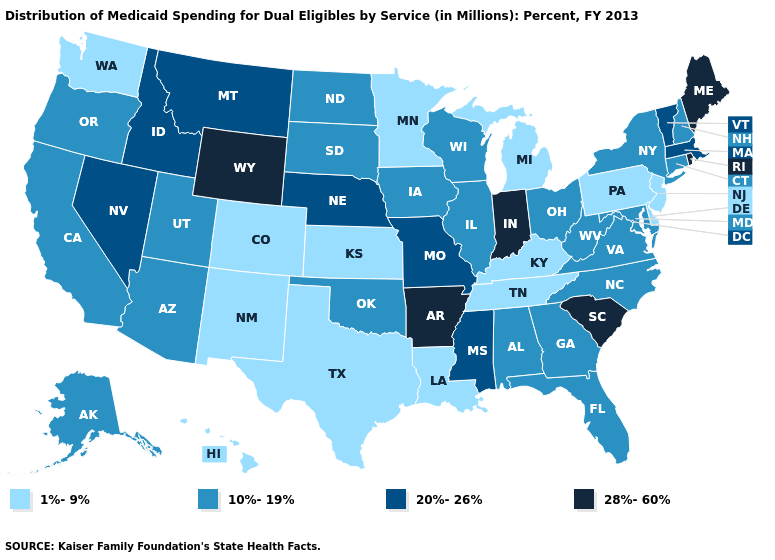Does Arkansas have the highest value in the South?
Write a very short answer. Yes. Among the states that border Kansas , does Nebraska have the highest value?
Give a very brief answer. Yes. Does Pennsylvania have the highest value in the USA?
Quick response, please. No. Among the states that border Michigan , which have the highest value?
Concise answer only. Indiana. What is the highest value in the USA?
Write a very short answer. 28%-60%. Does New Hampshire have a higher value than Montana?
Keep it brief. No. What is the highest value in states that border New Hampshire?
Write a very short answer. 28%-60%. Is the legend a continuous bar?
Keep it brief. No. Name the states that have a value in the range 10%-19%?
Concise answer only. Alabama, Alaska, Arizona, California, Connecticut, Florida, Georgia, Illinois, Iowa, Maryland, New Hampshire, New York, North Carolina, North Dakota, Ohio, Oklahoma, Oregon, South Dakota, Utah, Virginia, West Virginia, Wisconsin. Name the states that have a value in the range 10%-19%?
Give a very brief answer. Alabama, Alaska, Arizona, California, Connecticut, Florida, Georgia, Illinois, Iowa, Maryland, New Hampshire, New York, North Carolina, North Dakota, Ohio, Oklahoma, Oregon, South Dakota, Utah, Virginia, West Virginia, Wisconsin. Name the states that have a value in the range 1%-9%?
Give a very brief answer. Colorado, Delaware, Hawaii, Kansas, Kentucky, Louisiana, Michigan, Minnesota, New Jersey, New Mexico, Pennsylvania, Tennessee, Texas, Washington. Does South Dakota have the lowest value in the USA?
Quick response, please. No. Name the states that have a value in the range 20%-26%?
Quick response, please. Idaho, Massachusetts, Mississippi, Missouri, Montana, Nebraska, Nevada, Vermont. Among the states that border West Virginia , which have the highest value?
Concise answer only. Maryland, Ohio, Virginia. Name the states that have a value in the range 10%-19%?
Answer briefly. Alabama, Alaska, Arizona, California, Connecticut, Florida, Georgia, Illinois, Iowa, Maryland, New Hampshire, New York, North Carolina, North Dakota, Ohio, Oklahoma, Oregon, South Dakota, Utah, Virginia, West Virginia, Wisconsin. 